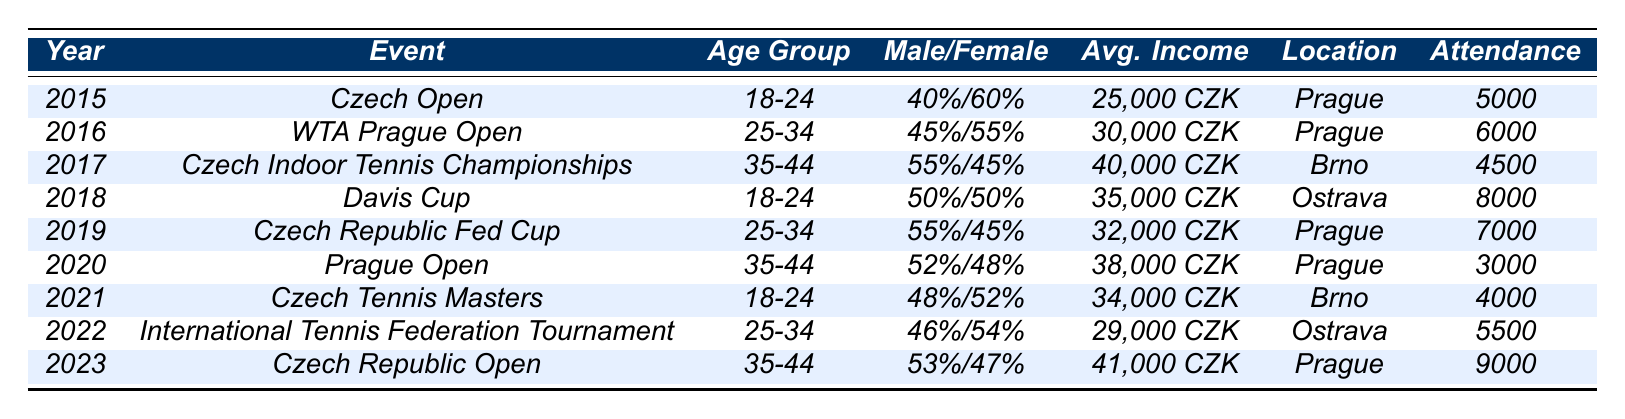What was the attendance at the Davis Cup in 2018? The table indicates that the attendance for the Davis Cup in 2018 was 8000.
Answer: 8000 In which year did the Czech Indoor Tennis Championships take place? The table shows that the Czech Indoor Tennis Championships occurred in 2017.
Answer: 2017 What is the average income for fans attending the Czech Republic Open in 2023? According to the table, the average income for fans attending the Czech Republic Open in 2023 is 41,000 CZK.
Answer: 41,000 CZK Which event in 2019 had the highest male percentage among fans? In 2019, the Czech Republic Fed Cup had a male percentage of 55%, which is the highest among all events listed.
Answer: 55% How many attendees were there at the Prague Open in 2020? The table indicates that 3000 attendees were present at the Prague Open in 2020.
Answer: 3000 Is the gender distribution for the Czech Tennis Masters in 2021 evenly split between male and female fans? The gender distribution for the Czech Tennis Masters in 2021 is 48% male and 52% female, indicating it is not evenly split.
Answer: No What was the percentage of male fans at the WTA Prague Open in 2016? According to the table, the percentage of male fans at the WTA Prague Open in 2016 was 45%.
Answer: 45% Which age group had the highest attendance in 2023? The age group 35-44 had the attendance of 9000 in 2023, which is the highest.
Answer: 35-44 Calculate the average attendance from 2015 to 2023. The total attendance adds up to 5000 + 6000 + 4500 + 8000 + 7000 + 3000 + 4000 + 5500 + 9000 = 49500. There are 9 years, so the average attendance is 49500 / 9 = 5500.
Answer: 5500 Did attendance generally increase from 2020 to 2023? The attendance increased from 3000 in 2020 to 9000 in 2023, showing a general increase over these years.
Answer: Yes What is the proportion of female fans in the age group 35-44 in 2018? The proportion of female fans in the age group 35-44 is 50% for the Davis Cup in 2018.
Answer: 50% 